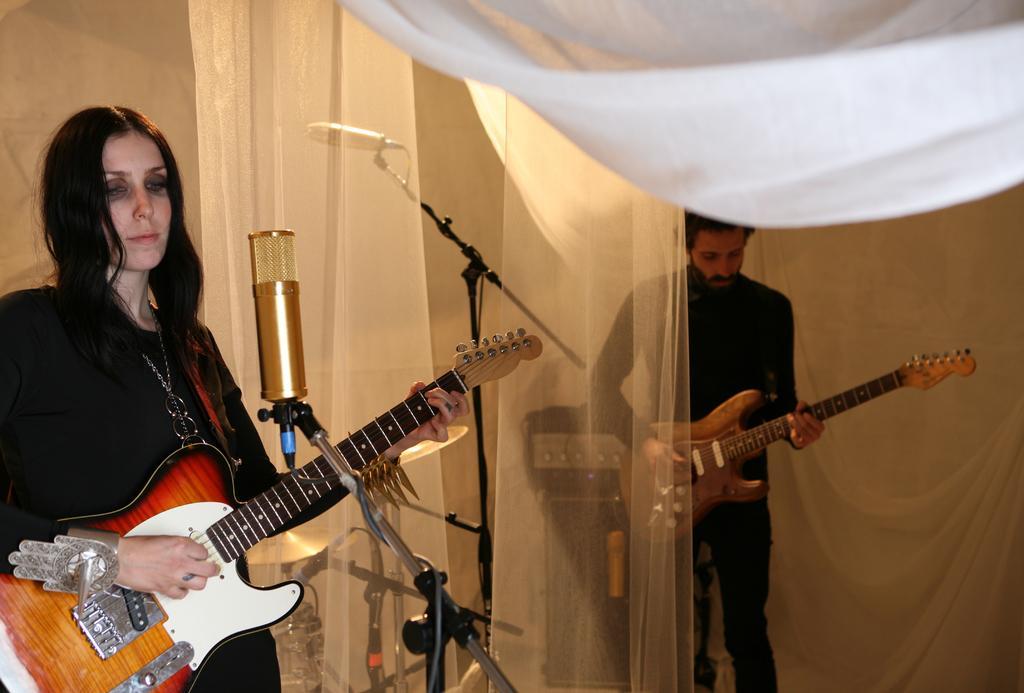Describe this image in one or two sentences. In this image I can see two people with black color dress and these people are playing the guitar. One person is standing in front of mic and there is a white curtain between them. 